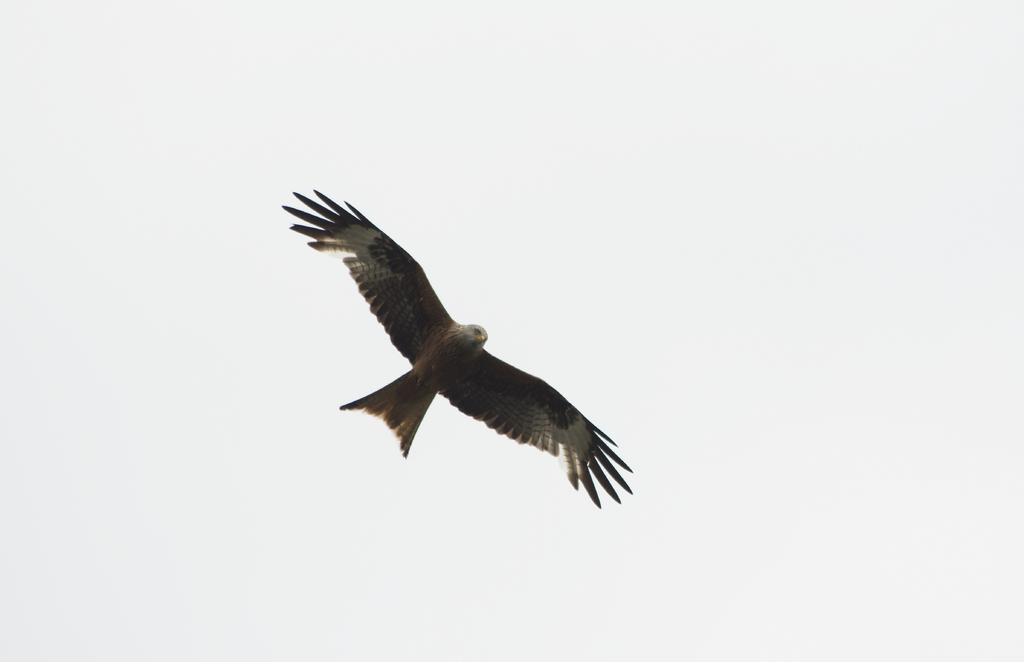Can you describe this image briefly? In this image there is a bird flying in the sky. 